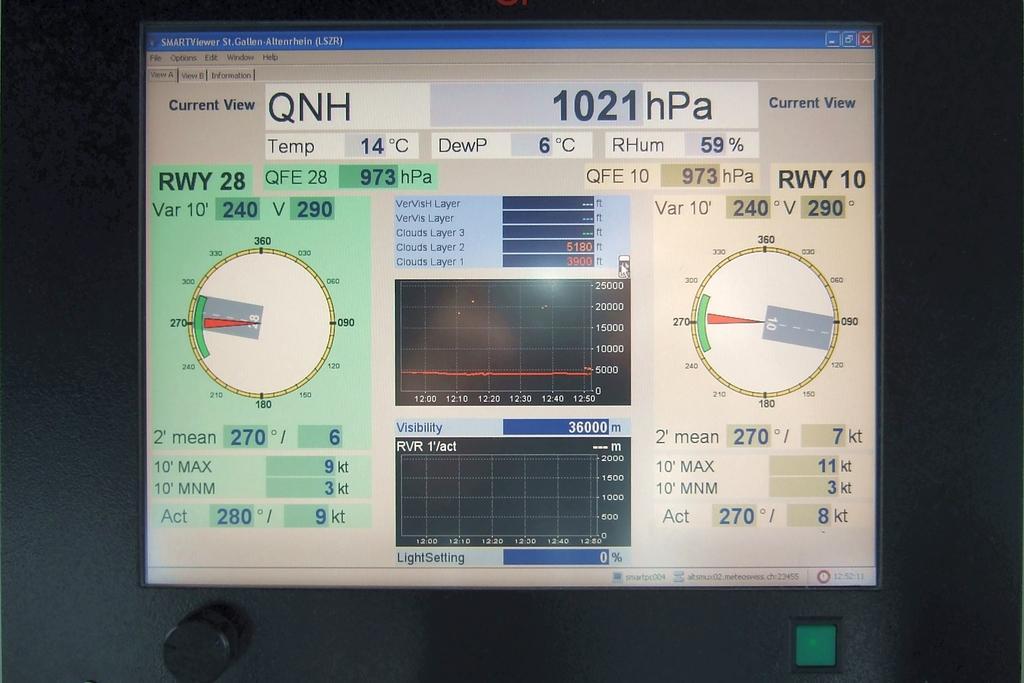Describe this image in one or two sentences. In this image I can see the screen and I can see something written on the screen and I can see the dark background. In front I can see the button in green color. 